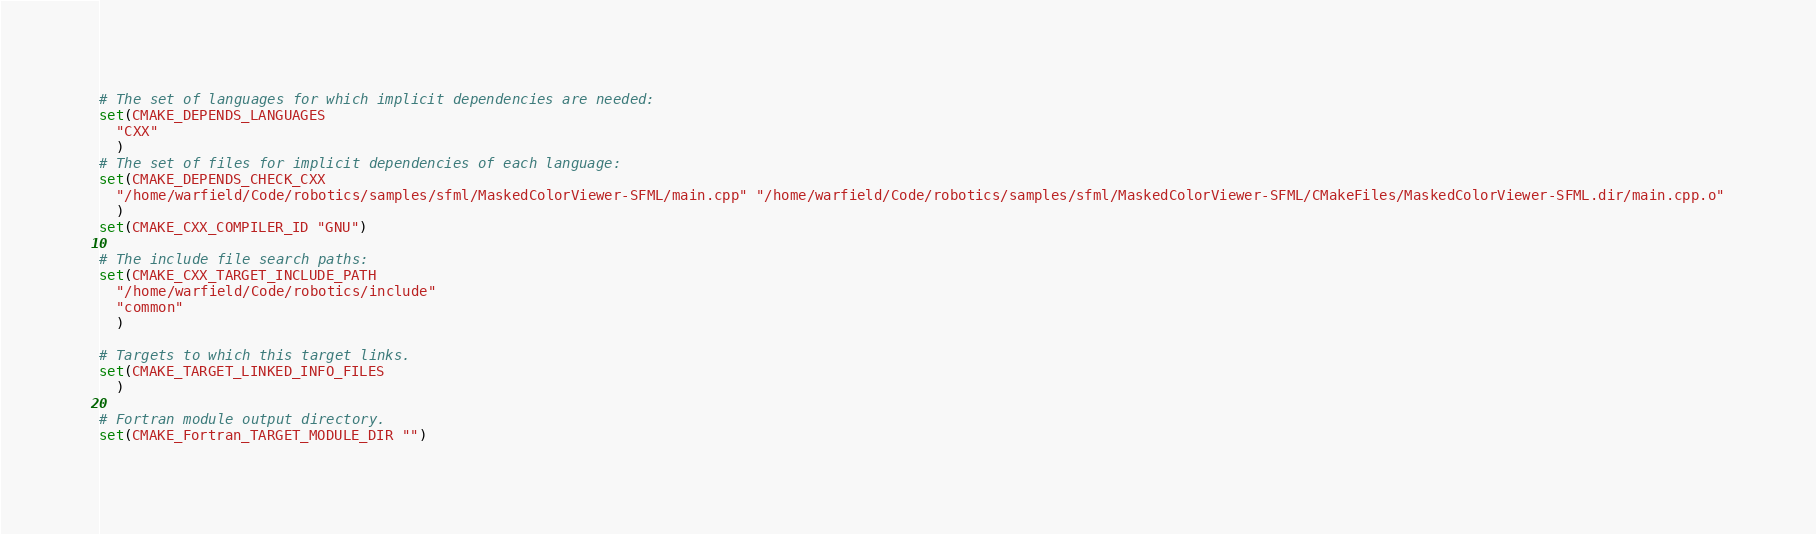<code> <loc_0><loc_0><loc_500><loc_500><_CMake_># The set of languages for which implicit dependencies are needed:
set(CMAKE_DEPENDS_LANGUAGES
  "CXX"
  )
# The set of files for implicit dependencies of each language:
set(CMAKE_DEPENDS_CHECK_CXX
  "/home/warfield/Code/robotics/samples/sfml/MaskedColorViewer-SFML/main.cpp" "/home/warfield/Code/robotics/samples/sfml/MaskedColorViewer-SFML/CMakeFiles/MaskedColorViewer-SFML.dir/main.cpp.o"
  )
set(CMAKE_CXX_COMPILER_ID "GNU")

# The include file search paths:
set(CMAKE_CXX_TARGET_INCLUDE_PATH
  "/home/warfield/Code/robotics/include"
  "common"
  )

# Targets to which this target links.
set(CMAKE_TARGET_LINKED_INFO_FILES
  )

# Fortran module output directory.
set(CMAKE_Fortran_TARGET_MODULE_DIR "")
</code> 